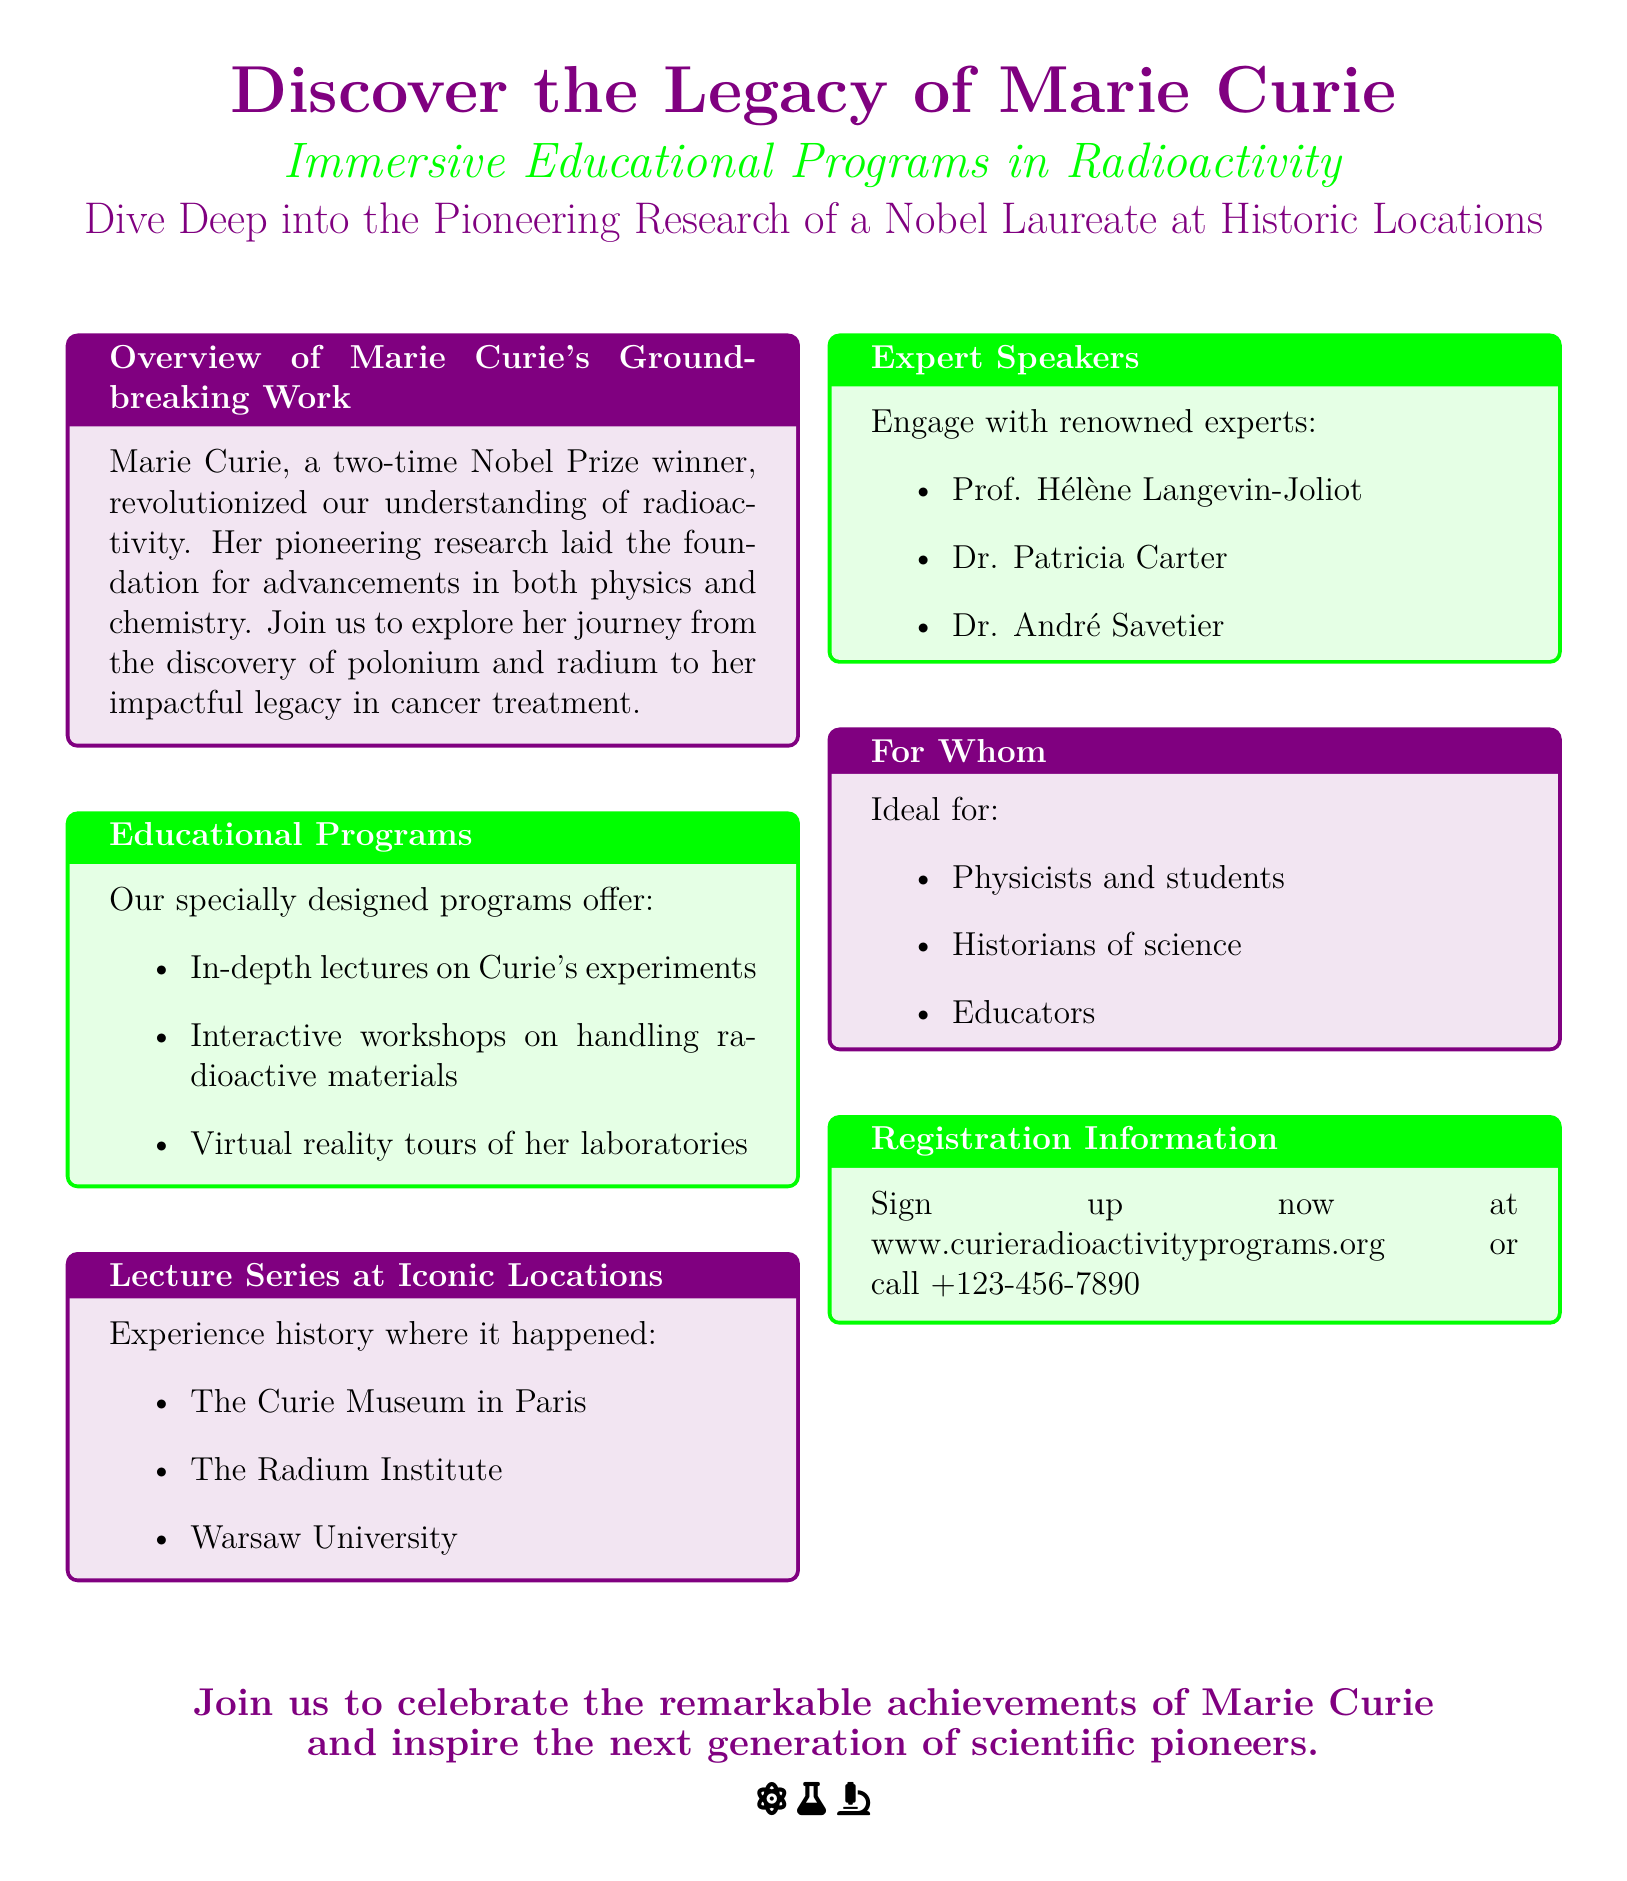What are the main themes of Marie Curie's work? The main themes are her discoveries of polonium and radium, and her legacy in cancer treatment.
Answer: Discoveries of polonium and radium, legacy in cancer treatment Which prestigious award did Marie Curie win twice? The prestigious award she won twice is the Nobel Prize.
Answer: Nobel Prize Name one location where the lecture series will take place. The document lists multiple locations; one example is the Curie Museum in Paris.
Answer: Curie Museum in Paris Who is one of the expert speakers mentioned? The document lists several expert speakers; one example is Prof. Hélène Langevin-Joliot.
Answer: Prof. Hélène Langevin-Joliot What type of educational programs are being offered? The programs include in-depth lectures, interactive workshops, and virtual reality tours.
Answer: In-depth lectures, interactive workshops, virtual reality tours Who is the intended audience for the programs? The intended audience includes physicists, historians of science, and educators.
Answer: Physicists, historians of science, educators What is the registration contact information? Registration contact information is provided as a website and a phone number.
Answer: www.curieradioactivityprograms.org or call +123-456-7890 What color is associated with Marie Curie's name in the document? The color associated with Marie Curie's name is purple.
Answer: Purple 